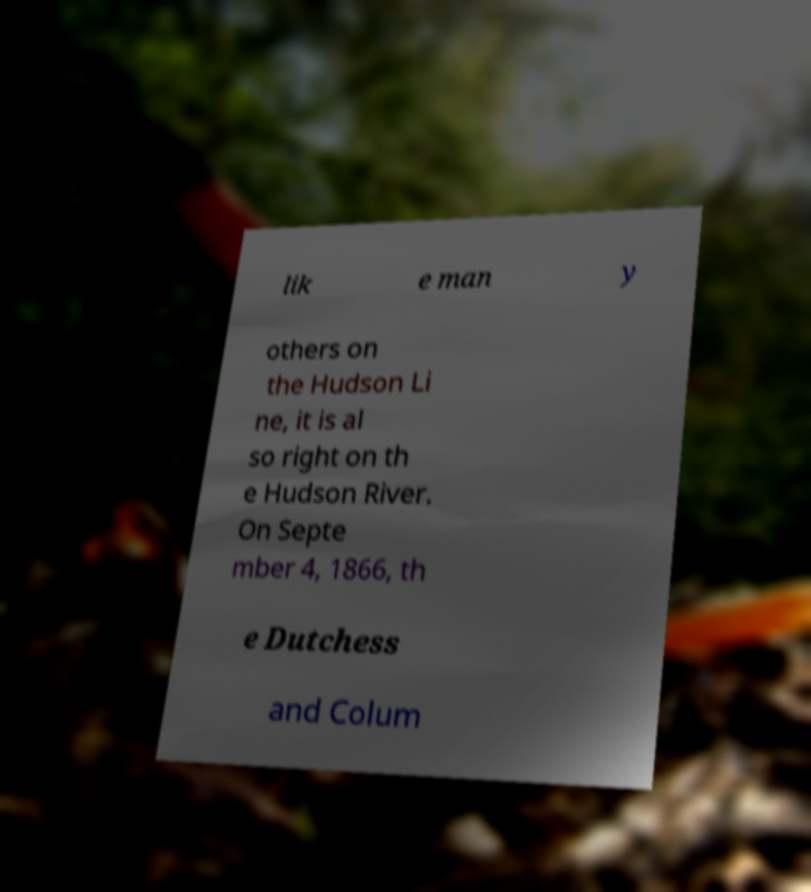I need the written content from this picture converted into text. Can you do that? lik e man y others on the Hudson Li ne, it is al so right on th e Hudson River. On Septe mber 4, 1866, th e Dutchess and Colum 